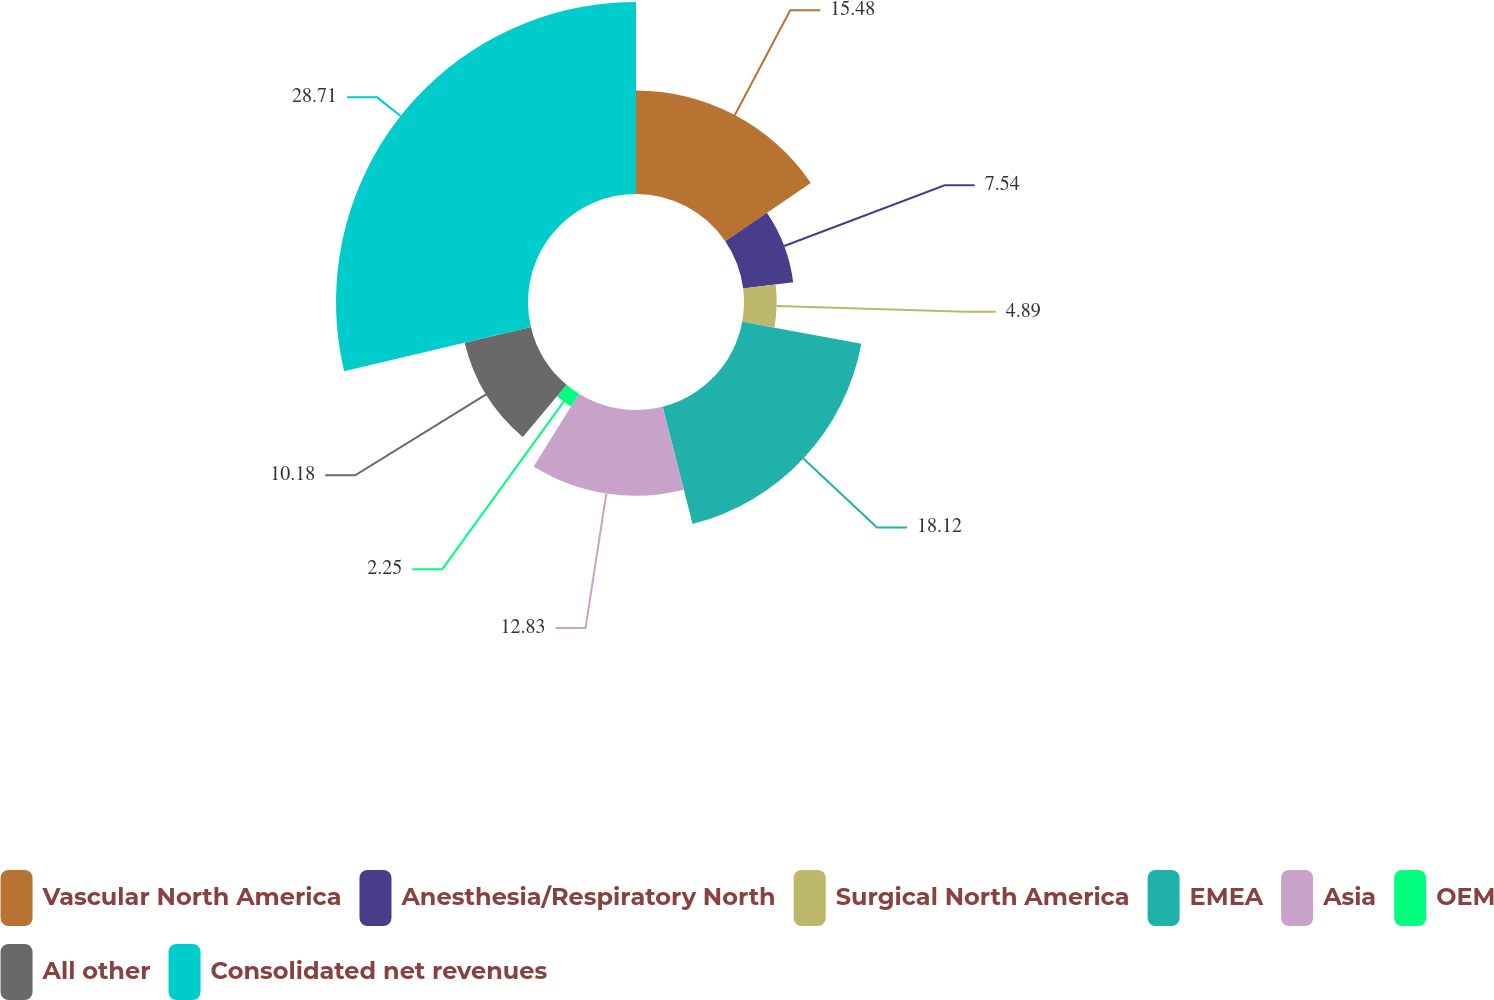Convert chart. <chart><loc_0><loc_0><loc_500><loc_500><pie_chart><fcel>Vascular North America<fcel>Anesthesia/Respiratory North<fcel>Surgical North America<fcel>EMEA<fcel>Asia<fcel>OEM<fcel>All other<fcel>Consolidated net revenues<nl><fcel>15.48%<fcel>7.54%<fcel>4.89%<fcel>18.12%<fcel>12.83%<fcel>2.25%<fcel>10.18%<fcel>28.71%<nl></chart> 